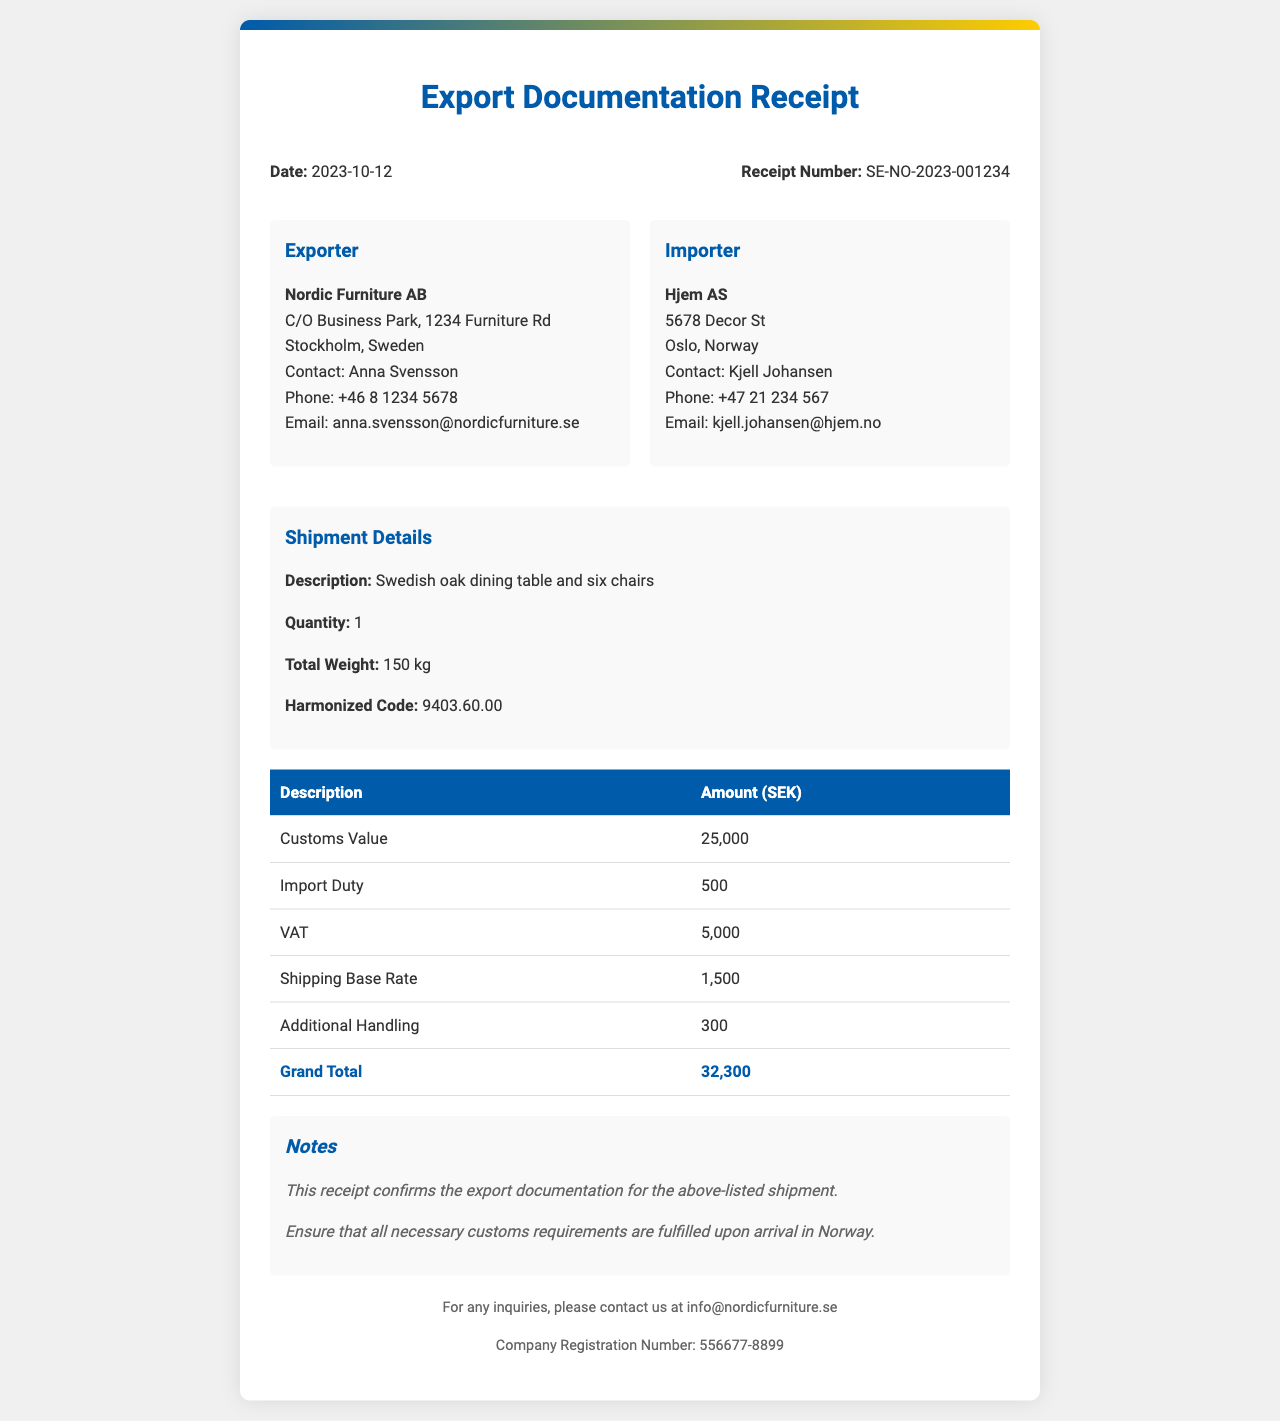what is the date of the receipt? The date is explicitly stated in the document header.
Answer: 2023-10-12 what is the receipt number? The receipt number is presented in the header section of the document.
Answer: SE-NO-2023-001234 who is the exporter? The document contains details about the exporter in a separate section.
Answer: Nordic Furniture AB who is the importer? The importer's information is outlined in the respective section of the document.
Answer: Hjem AS what is the customs value? The customs value is one of the specific financial entries listed in the table.
Answer: 25,000 what is the grand total amount? The grand total is calculated and displayed in the table as the final entry.
Answer: 32,300 what is the total weight of the shipment? The total weight is mentioned in the shipment details section.
Answer: 150 kg what is the VAT amount? The VAT is listed in the financial breakdown table among other charges.
Answer: 5,000 what is the harmonized code for the shipment? The harmonized code is specified under shipment details.
Answer: 9403.60.00 